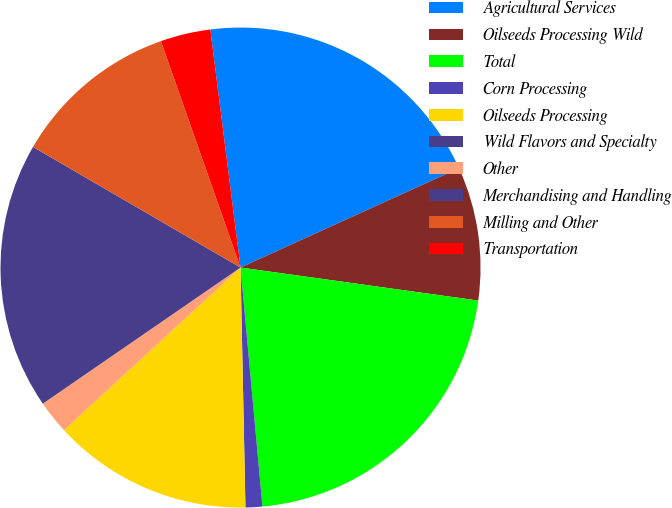<chart> <loc_0><loc_0><loc_500><loc_500><pie_chart><fcel>Agricultural Services<fcel>Oilseeds Processing Wild<fcel>Total<fcel>Corn Processing<fcel>Oilseeds Processing<fcel>Wild Flavors and Specialty<fcel>Other<fcel>Merchandising and Handling<fcel>Milling and Other<fcel>Transportation<nl><fcel>20.22%<fcel>8.99%<fcel>21.35%<fcel>1.13%<fcel>13.48%<fcel>0.0%<fcel>2.25%<fcel>17.98%<fcel>11.24%<fcel>3.37%<nl></chart> 